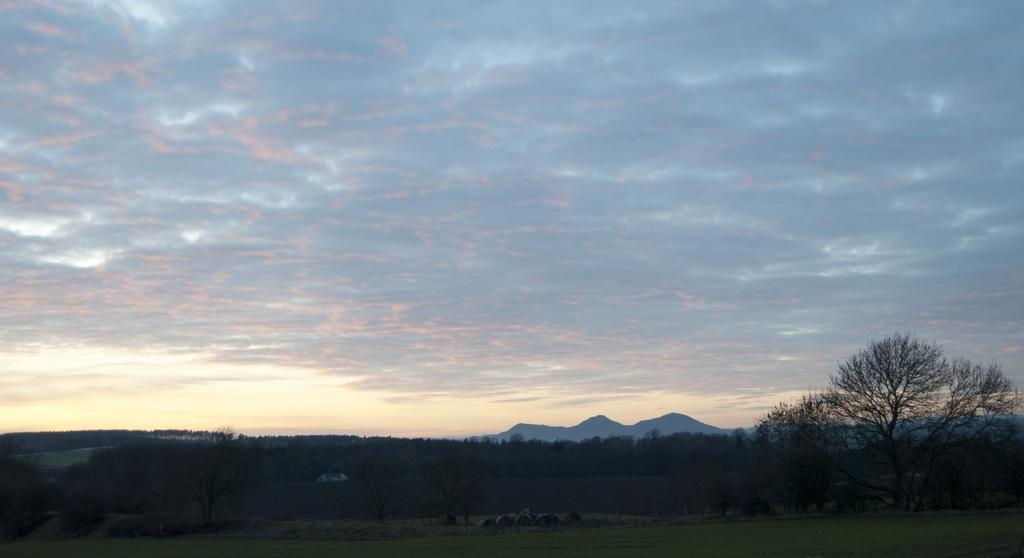What type of vegetation is present in the image? There are trees in the image. What natural feature can be seen in the distance? There are mountains in the background of the image. What colors are visible in the sky in the image? The sky is visible in the image, with blue and white colors. Is there a health clinic visible in the image? No, there is no health clinic present in the image. Can you describe the rainstorm happening in the image? There is no rainstorm present in the image; the sky is visible with blue and white colors. 